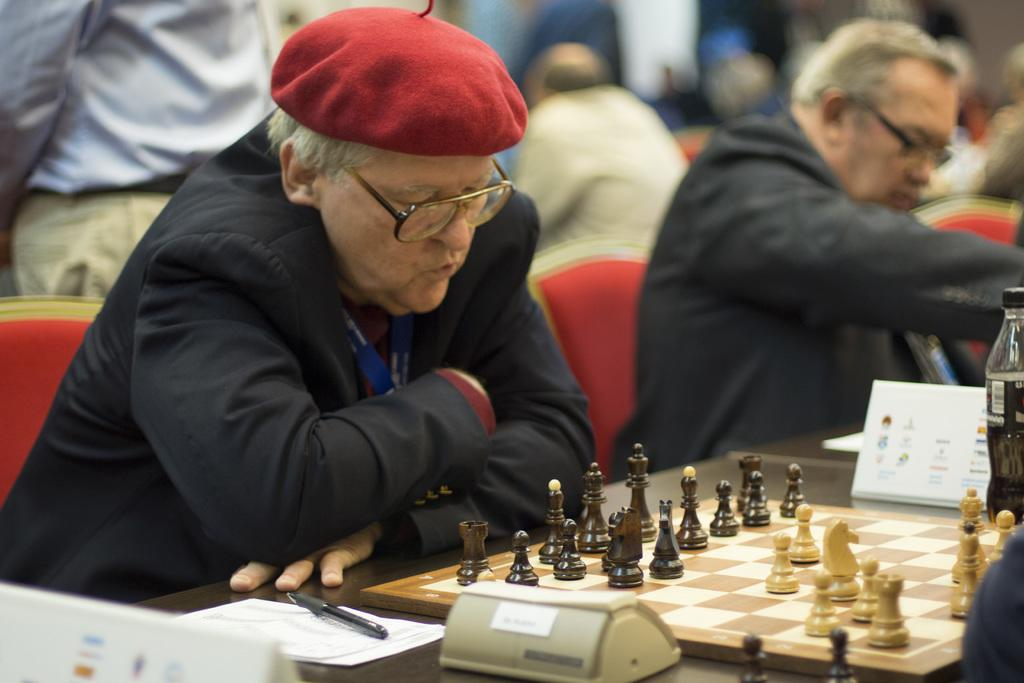What is the man in the image doing? The man is sitting in front of a table in the image. What is on the table in the image? There is a chess board on the table, and there are other items on the table as well. Can you describe the people around the man? There are other people around the man in the image. What might the man and the other people be engaged in? They might be playing a game, such as chess, given the presence of a chess board on the table. What type of grass is growing on the man's head in the image? There is no grass growing on the man's head in the image. What material is the man's heart made of in the image? There is no mention of a heart in the image, and therefore we cannot determine its material. 